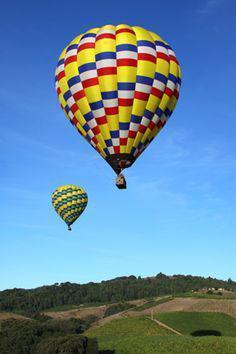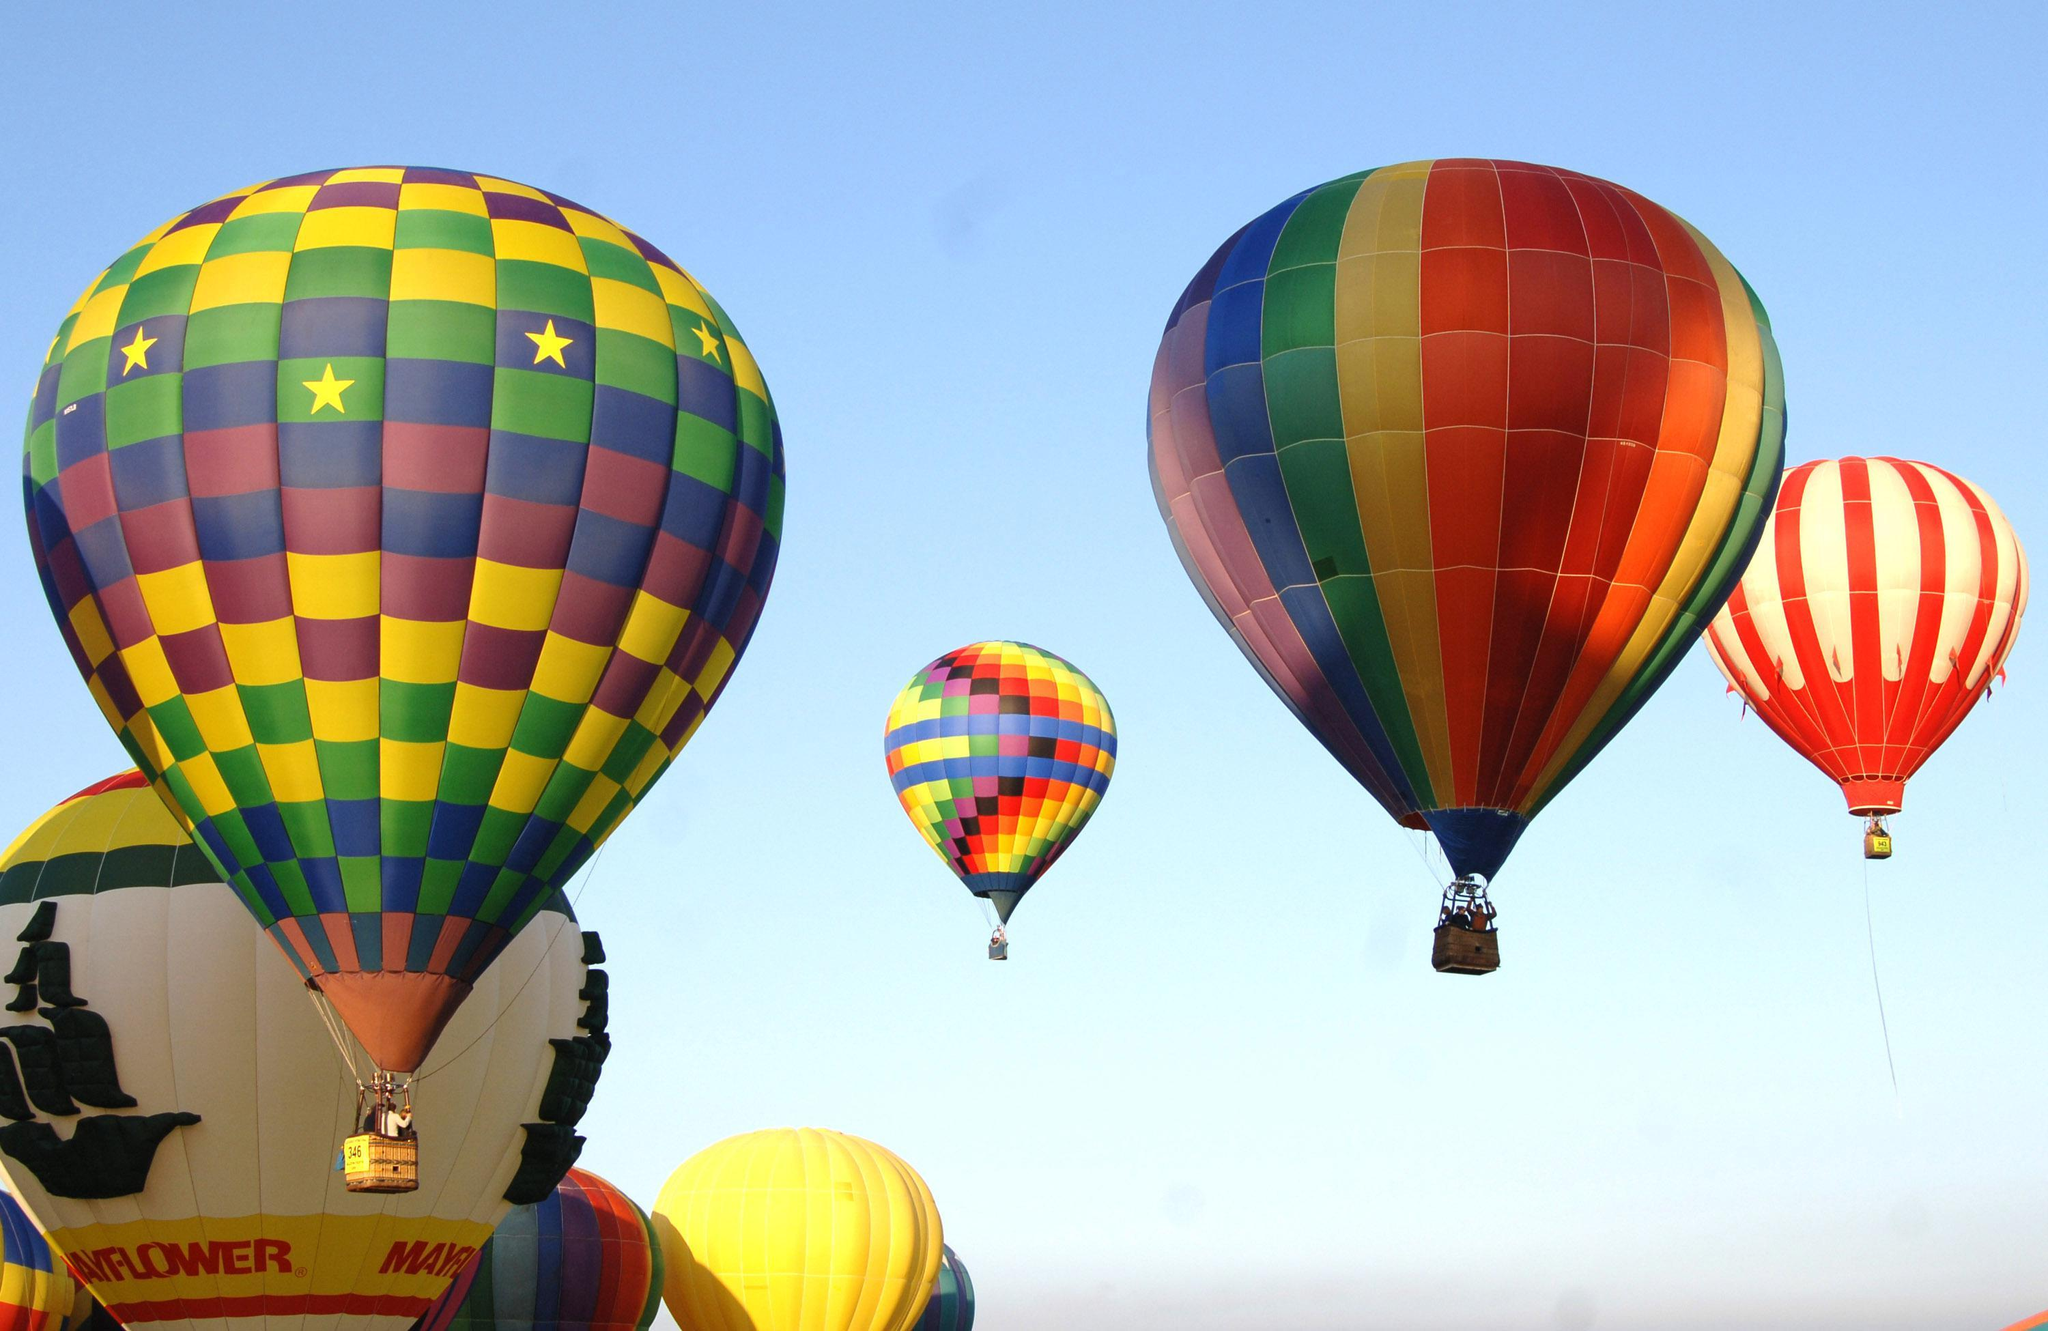The first image is the image on the left, the second image is the image on the right. Analyze the images presented: Is the assertion "Only one image shows a hot air balloon made of many balloons." valid? Answer yes or no. No. The first image is the image on the left, the second image is the image on the right. Given the left and right images, does the statement "One hot air balloon appears to be made of many small balloons and its basket is a little house." hold true? Answer yes or no. No. 